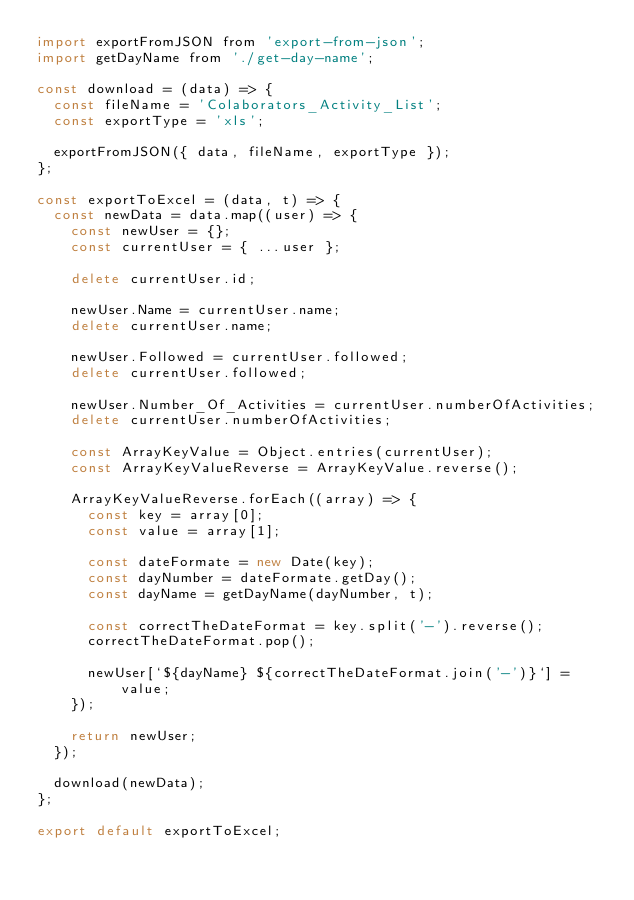<code> <loc_0><loc_0><loc_500><loc_500><_JavaScript_>import exportFromJSON from 'export-from-json';
import getDayName from './get-day-name';

const download = (data) => {
  const fileName = 'Colaborators_Activity_List';
  const exportType = 'xls';

  exportFromJSON({ data, fileName, exportType });
};

const exportToExcel = (data, t) => {
  const newData = data.map((user) => {
    const newUser = {};
    const currentUser = { ...user };

    delete currentUser.id;

    newUser.Name = currentUser.name;
    delete currentUser.name;

    newUser.Followed = currentUser.followed;
    delete currentUser.followed;

    newUser.Number_Of_Activities = currentUser.numberOfActivities;
    delete currentUser.numberOfActivities;

    const ArrayKeyValue = Object.entries(currentUser);
    const ArrayKeyValueReverse = ArrayKeyValue.reverse();

    ArrayKeyValueReverse.forEach((array) => {
      const key = array[0];
      const value = array[1];

      const dateFormate = new Date(key);
      const dayNumber = dateFormate.getDay();
      const dayName = getDayName(dayNumber, t);

      const correctTheDateFormat = key.split('-').reverse();
      correctTheDateFormat.pop();

      newUser[`${dayName} ${correctTheDateFormat.join('-')}`] = value;
    });

    return newUser;
  });

  download(newData);
};

export default exportToExcel;
</code> 